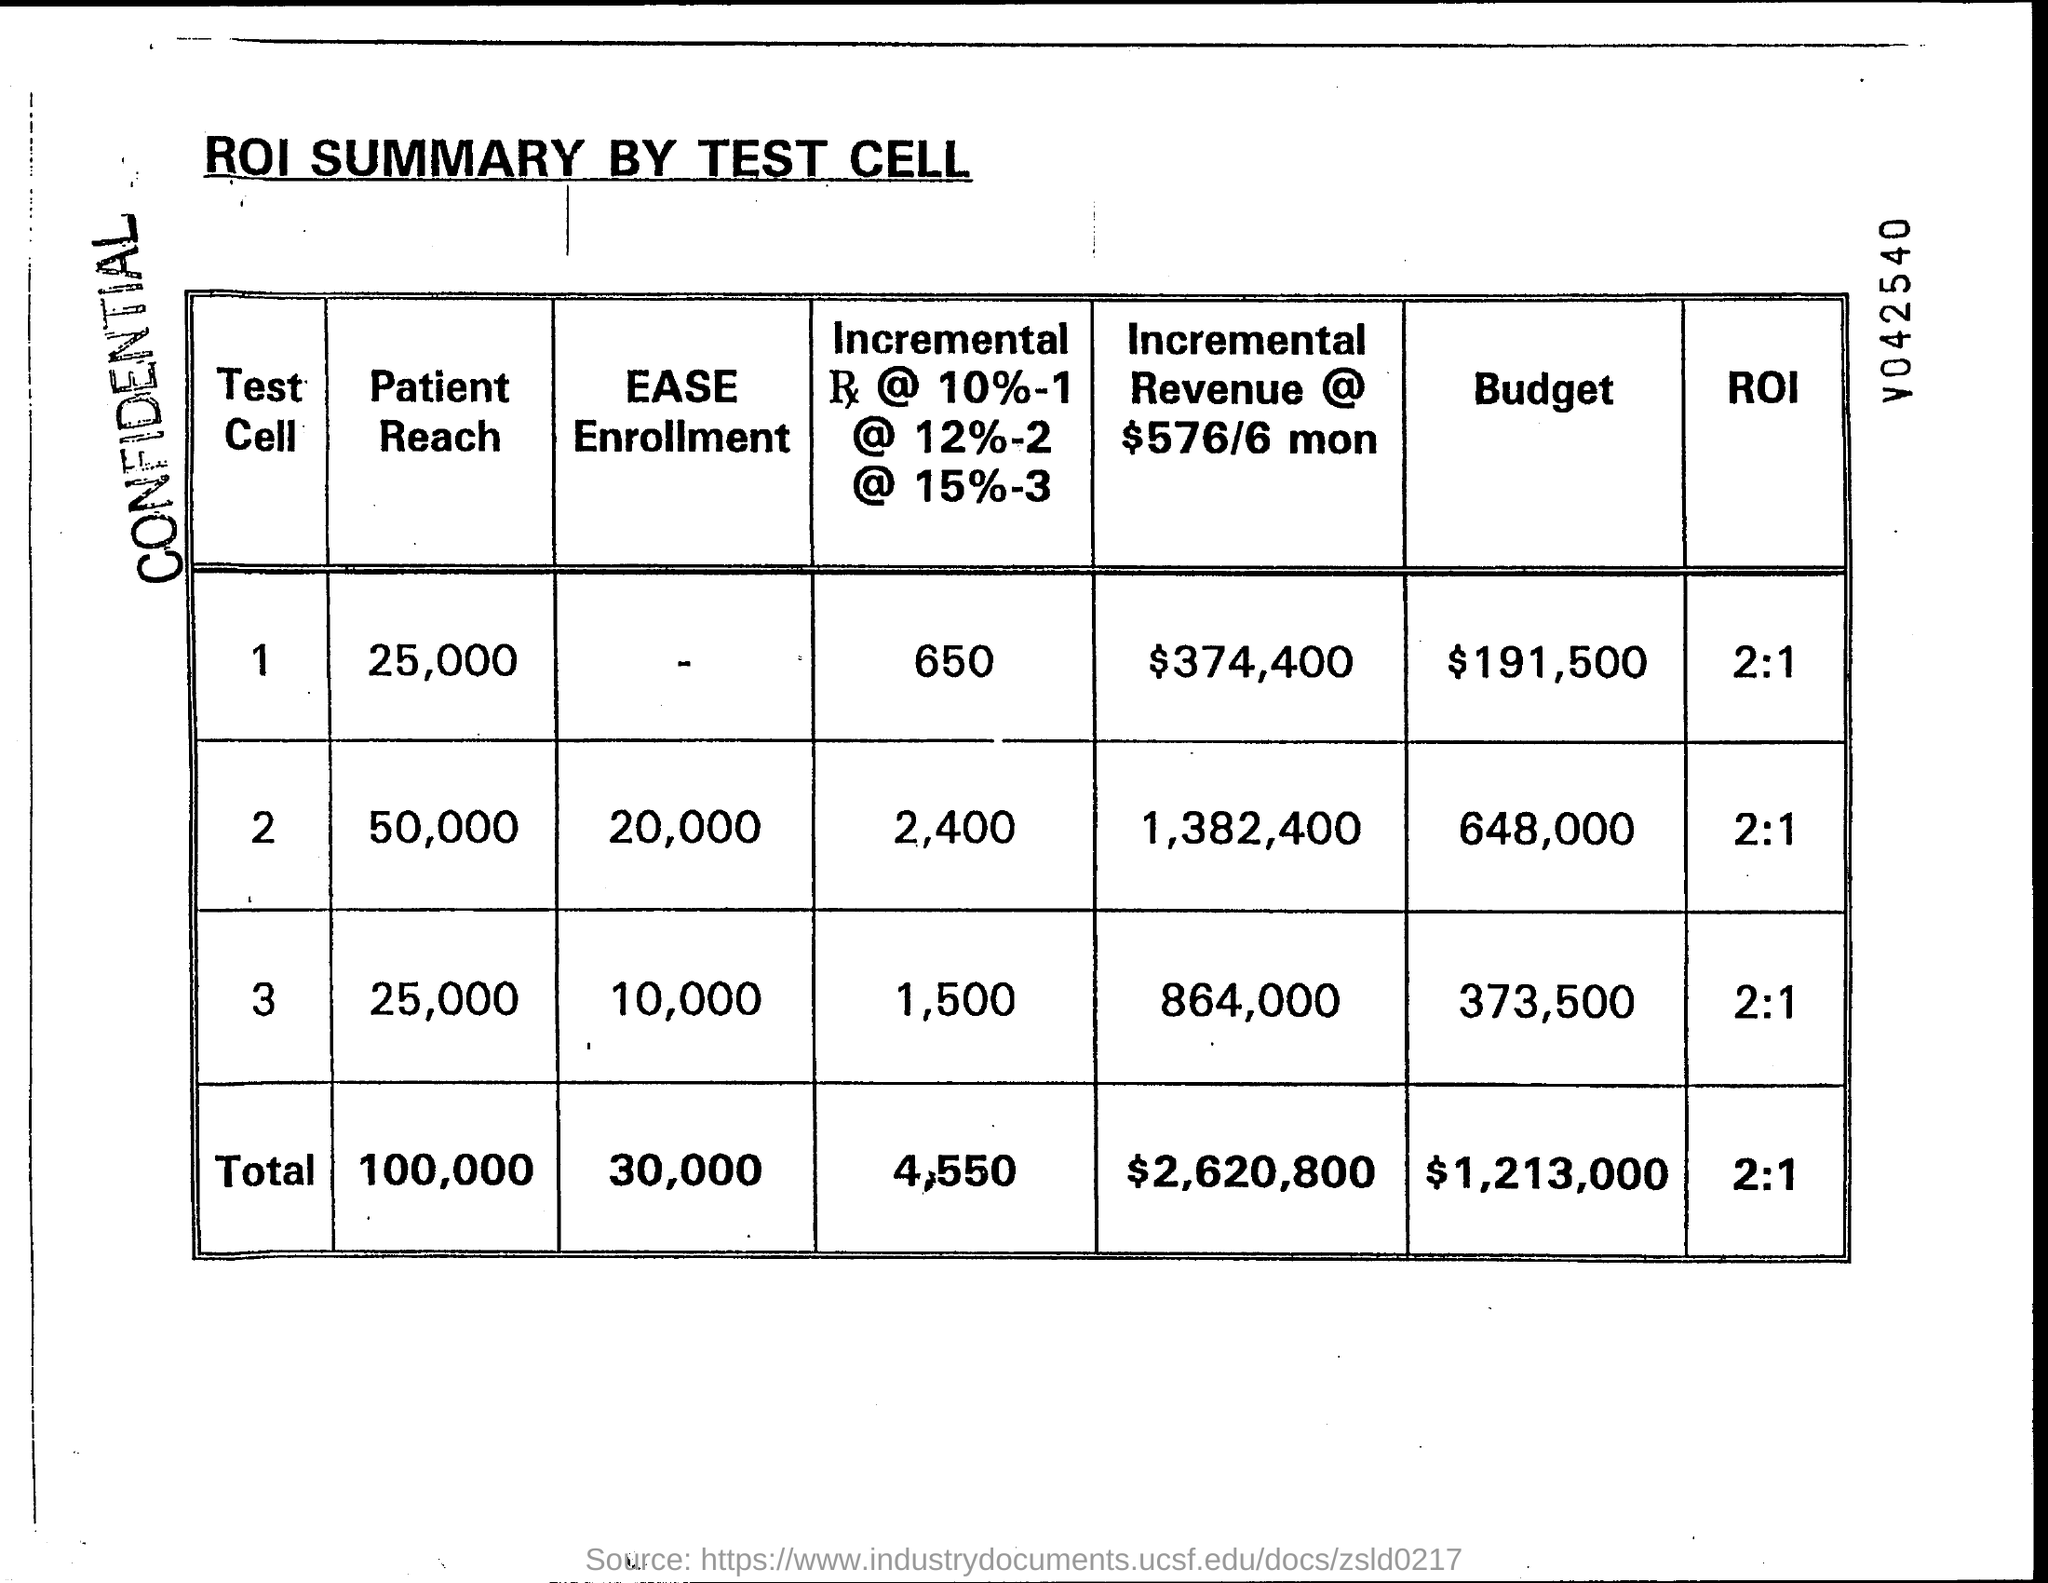What might the different test cells represent in this ROI summary? The different test cells in the ROI summary likely represent separate scenarios or strategies employed during a marketing or clinical testing phase. Each cell has been analyzed to understand its reach, enrollment efficiency, incremental revenue, budget, and ROI, allowing the organization to compare the performance and outcomes of each strategy or test group. 